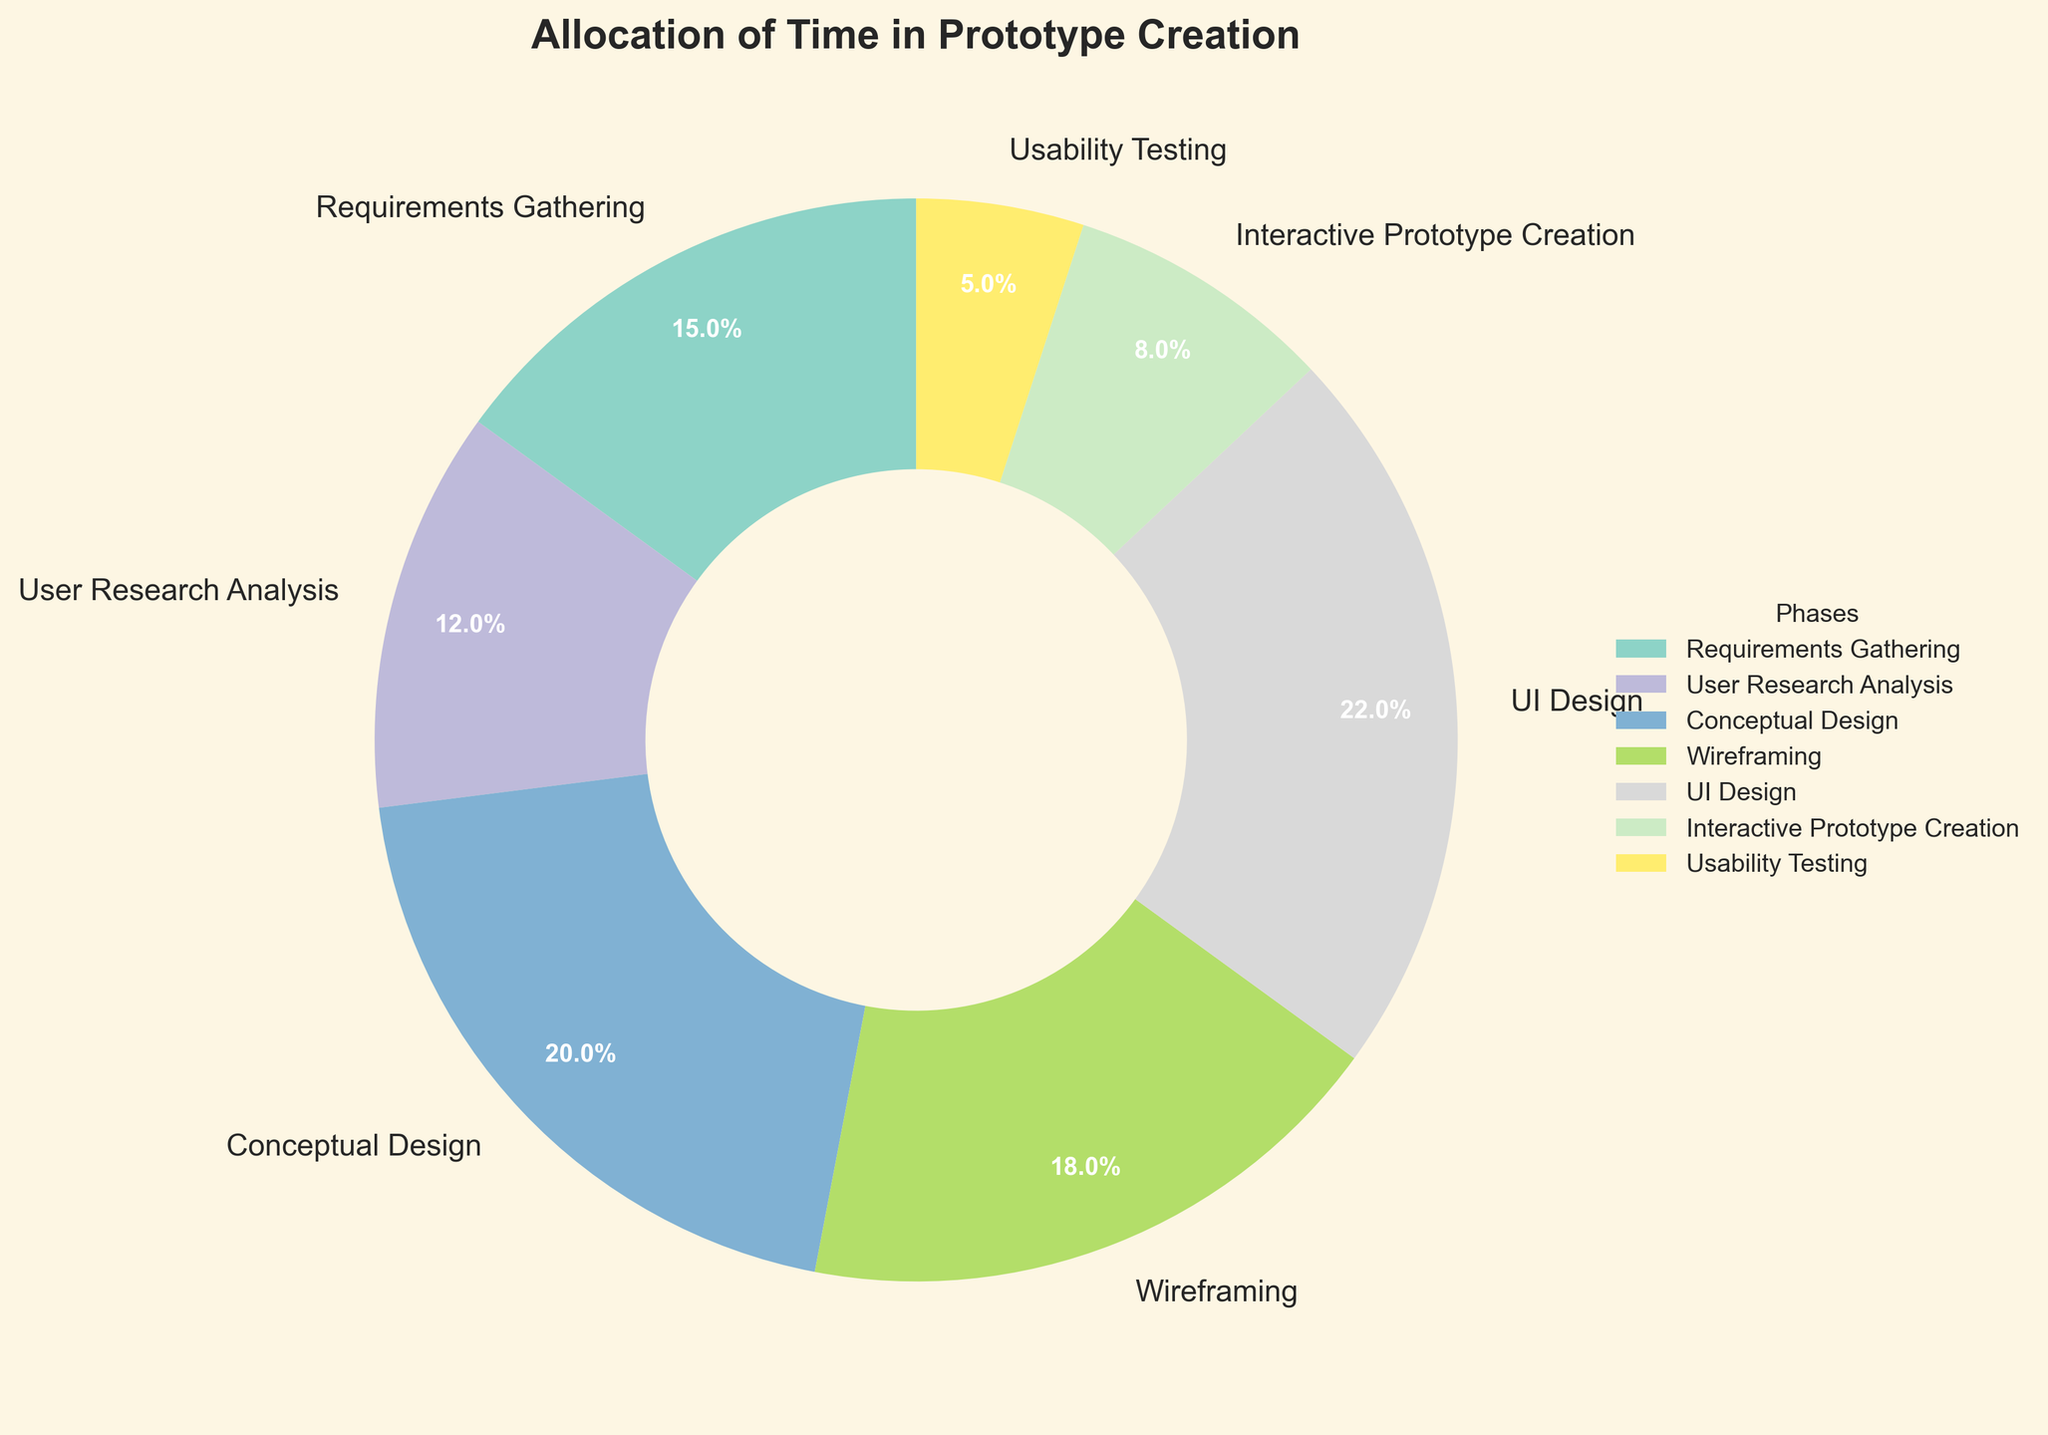Which phase takes up the largest percentage of time? By looking at the pie chart, the phase segment that occupies the most space signifies the largest percentage. The "UI Design" phase is the largest segment.
Answer: UI Design Which phase takes the smallest percentage of time? Observing the pie chart, the phase segment that covers the least space signifies the smallest percentage. The "Usability Testing" phase is the smallest segment.
Answer: Usability Testing What is the combined percentage of time spent on Requirements Gathering and User Research Analysis? Locate the segments for both "Requirements Gathering" and "User Research Analysis" phases in the pie chart and sum their percentages: 15% + 12% = 27%.
Answer: 27% How does the percentage of time spent on Wireframing compare to that on Interactive Prototype Creation? Compare the sizes of the segments in the pie chart for "Wireframing" and "Interactive Prototype Creation". The "Wireframing" phase (18%) is larger than "Interactive Prototype Creation" (8%).
Answer: Wireframing is larger What is the average percentage of time spent on Conceptual Design, Wireframing, and UI Design? Calculate the sum of the percentages for the three phases and then divide by 3: (20% + 18% + 22%) / 3 = 60% / 3 = 20%.
Answer: 20% How does the time spent on User Research Analysis differ from that on Usability Testing? Subtract the percentage of "Usability Testing" from "User Research Analysis": 12% - 5% = 7%.
Answer: 7% What is the total percentage of time spent on phases other than Interactive Prototype Creation? Sum the percentages of all phases except "Interactive Prototype Creation": 15% + 12% + 20% + 18% + 22% + 5% = 92%.
Answer: 92% What colors represent the Wireframing and Usability Testing phases? Observe the pie chart to identify the colors of the segments representing "Wireframing" and "Usability Testing". The "Wireframing" phase is represented by a specific color, as is the "Usability Testing" phase.
Answer: Wireframing: (specific color), Usability Testing: (specific color) What is the median percentage time spent across all phases? Sort the percentages in ascending order and find the middle value. The sorted percentages are: 5%, 8%, 12%, 15%, 18%, 20%, 22%. The median is the fourth value, which is 15%.
Answer: 15% Which phases collectively account for less than 15% of the time each, and what is their combined percentage? Identify the segments less than 15% in the pie chart: "User Research Analysis", "Interactive Prototype Creation", and "Usability Testing". Sum their percentages: 12% + 8% + 5% = 25%.
Answer: User Research Analysis, Interactive Prototype Creation, Usability Testing; 25% 